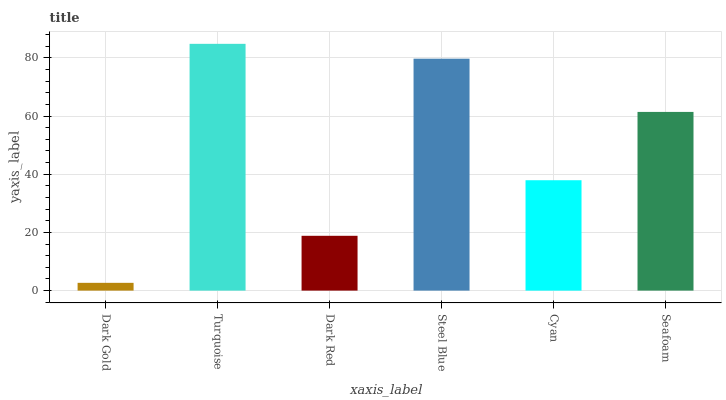Is Dark Gold the minimum?
Answer yes or no. Yes. Is Turquoise the maximum?
Answer yes or no. Yes. Is Dark Red the minimum?
Answer yes or no. No. Is Dark Red the maximum?
Answer yes or no. No. Is Turquoise greater than Dark Red?
Answer yes or no. Yes. Is Dark Red less than Turquoise?
Answer yes or no. Yes. Is Dark Red greater than Turquoise?
Answer yes or no. No. Is Turquoise less than Dark Red?
Answer yes or no. No. Is Seafoam the high median?
Answer yes or no. Yes. Is Cyan the low median?
Answer yes or no. Yes. Is Dark Red the high median?
Answer yes or no. No. Is Steel Blue the low median?
Answer yes or no. No. 